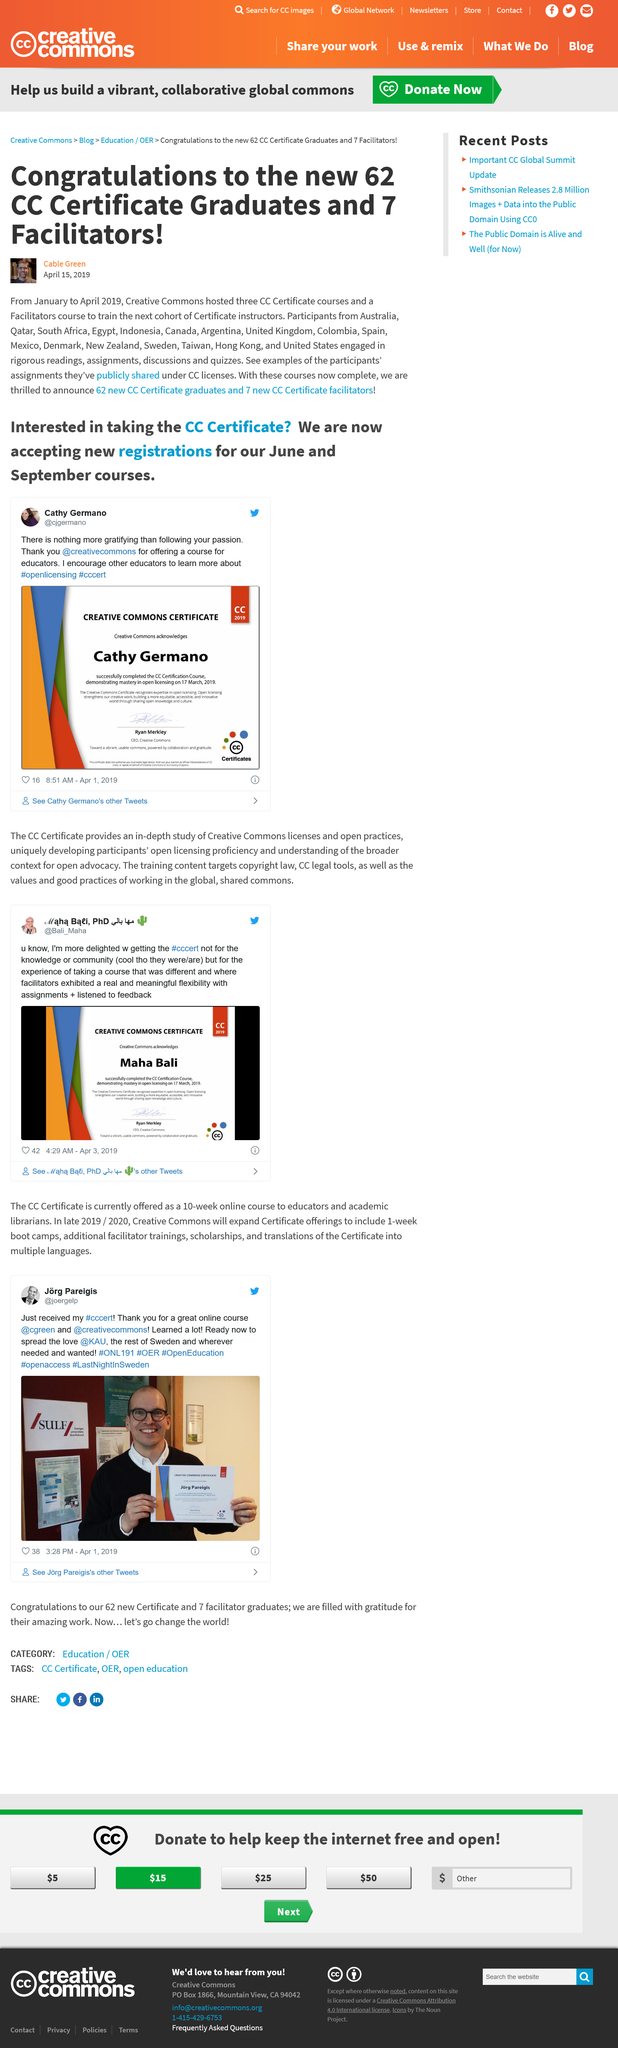Give some essential details in this illustration. There were 7 facilitators present. Creative Commons hosted three CC Certificate courses. There were 62 CC certificate graduates in total. 